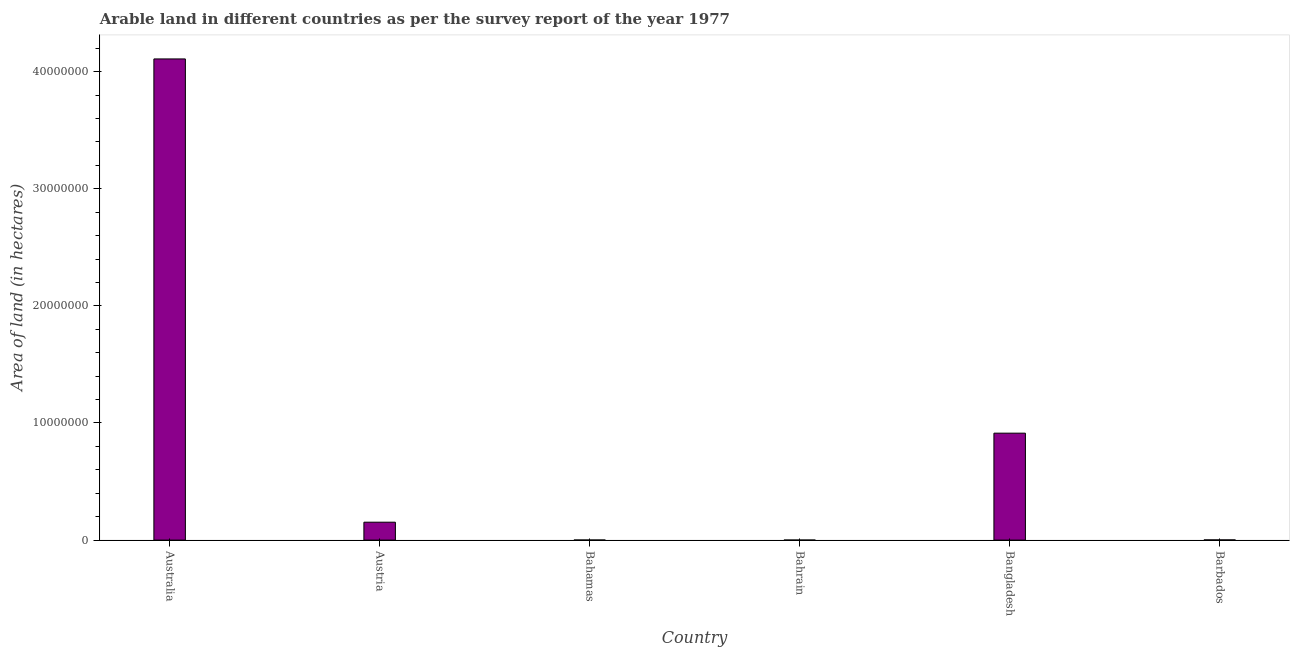Does the graph contain any zero values?
Give a very brief answer. No. What is the title of the graph?
Your answer should be compact. Arable land in different countries as per the survey report of the year 1977. What is the label or title of the Y-axis?
Keep it short and to the point. Area of land (in hectares). What is the area of land in Bangladesh?
Keep it short and to the point. 9.13e+06. Across all countries, what is the maximum area of land?
Offer a very short reply. 4.11e+07. Across all countries, what is the minimum area of land?
Your response must be concise. 2000. In which country was the area of land minimum?
Your response must be concise. Bahrain. What is the sum of the area of land?
Your answer should be very brief. 5.18e+07. What is the difference between the area of land in Australia and Austria?
Ensure brevity in your answer.  3.96e+07. What is the average area of land per country?
Your answer should be compact. 8.63e+06. What is the median area of land?
Give a very brief answer. 7.72e+05. In how many countries, is the area of land greater than 6000000 hectares?
Offer a very short reply. 2. What is the ratio of the area of land in Bahamas to that in Barbados?
Ensure brevity in your answer.  0.44. What is the difference between the highest and the second highest area of land?
Offer a terse response. 3.20e+07. What is the difference between the highest and the lowest area of land?
Your response must be concise. 4.11e+07. In how many countries, is the area of land greater than the average area of land taken over all countries?
Provide a succinct answer. 2. How many bars are there?
Your response must be concise. 6. Are the values on the major ticks of Y-axis written in scientific E-notation?
Give a very brief answer. No. What is the Area of land (in hectares) of Australia?
Keep it short and to the point. 4.11e+07. What is the Area of land (in hectares) in Austria?
Your answer should be very brief. 1.53e+06. What is the Area of land (in hectares) of Bahamas?
Provide a short and direct response. 7000. What is the Area of land (in hectares) of Bahrain?
Keep it short and to the point. 2000. What is the Area of land (in hectares) in Bangladesh?
Ensure brevity in your answer.  9.13e+06. What is the Area of land (in hectares) in Barbados?
Make the answer very short. 1.60e+04. What is the difference between the Area of land (in hectares) in Australia and Austria?
Offer a very short reply. 3.96e+07. What is the difference between the Area of land (in hectares) in Australia and Bahamas?
Your answer should be very brief. 4.11e+07. What is the difference between the Area of land (in hectares) in Australia and Bahrain?
Provide a succinct answer. 4.11e+07. What is the difference between the Area of land (in hectares) in Australia and Bangladesh?
Ensure brevity in your answer.  3.20e+07. What is the difference between the Area of land (in hectares) in Australia and Barbados?
Ensure brevity in your answer.  4.11e+07. What is the difference between the Area of land (in hectares) in Austria and Bahamas?
Offer a terse response. 1.52e+06. What is the difference between the Area of land (in hectares) in Austria and Bahrain?
Your response must be concise. 1.53e+06. What is the difference between the Area of land (in hectares) in Austria and Bangladesh?
Your response must be concise. -7.60e+06. What is the difference between the Area of land (in hectares) in Austria and Barbados?
Make the answer very short. 1.51e+06. What is the difference between the Area of land (in hectares) in Bahamas and Bahrain?
Give a very brief answer. 5000. What is the difference between the Area of land (in hectares) in Bahamas and Bangladesh?
Ensure brevity in your answer.  -9.12e+06. What is the difference between the Area of land (in hectares) in Bahamas and Barbados?
Make the answer very short. -9000. What is the difference between the Area of land (in hectares) in Bahrain and Bangladesh?
Provide a succinct answer. -9.13e+06. What is the difference between the Area of land (in hectares) in Bahrain and Barbados?
Make the answer very short. -1.40e+04. What is the difference between the Area of land (in hectares) in Bangladesh and Barbados?
Keep it short and to the point. 9.12e+06. What is the ratio of the Area of land (in hectares) in Australia to that in Austria?
Offer a terse response. 26.87. What is the ratio of the Area of land (in hectares) in Australia to that in Bahamas?
Offer a terse response. 5869.57. What is the ratio of the Area of land (in hectares) in Australia to that in Bahrain?
Your response must be concise. 2.05e+04. What is the ratio of the Area of land (in hectares) in Australia to that in Bangladesh?
Your answer should be compact. 4.5. What is the ratio of the Area of land (in hectares) in Australia to that in Barbados?
Your answer should be compact. 2567.94. What is the ratio of the Area of land (in hectares) in Austria to that in Bahamas?
Ensure brevity in your answer.  218.43. What is the ratio of the Area of land (in hectares) in Austria to that in Bahrain?
Provide a short and direct response. 764.5. What is the ratio of the Area of land (in hectares) in Austria to that in Bangladesh?
Make the answer very short. 0.17. What is the ratio of the Area of land (in hectares) in Austria to that in Barbados?
Make the answer very short. 95.56. What is the ratio of the Area of land (in hectares) in Bahamas to that in Bahrain?
Provide a short and direct response. 3.5. What is the ratio of the Area of land (in hectares) in Bahamas to that in Barbados?
Give a very brief answer. 0.44. What is the ratio of the Area of land (in hectares) in Bahrain to that in Bangladesh?
Give a very brief answer. 0. What is the ratio of the Area of land (in hectares) in Bahrain to that in Barbados?
Your answer should be very brief. 0.12. What is the ratio of the Area of land (in hectares) in Bangladesh to that in Barbados?
Offer a very short reply. 570.69. 